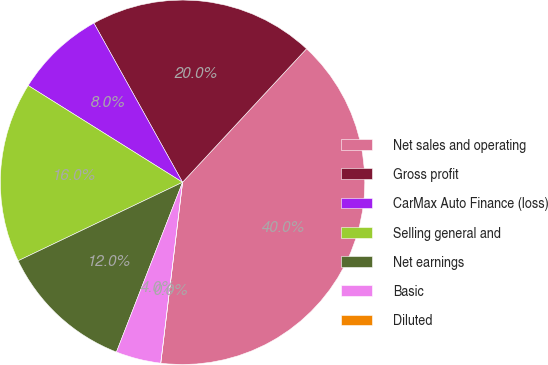<chart> <loc_0><loc_0><loc_500><loc_500><pie_chart><fcel>Net sales and operating<fcel>Gross profit<fcel>CarMax Auto Finance (loss)<fcel>Selling general and<fcel>Net earnings<fcel>Basic<fcel>Diluted<nl><fcel>40.0%<fcel>20.0%<fcel>8.0%<fcel>16.0%<fcel>12.0%<fcel>4.0%<fcel>0.0%<nl></chart> 